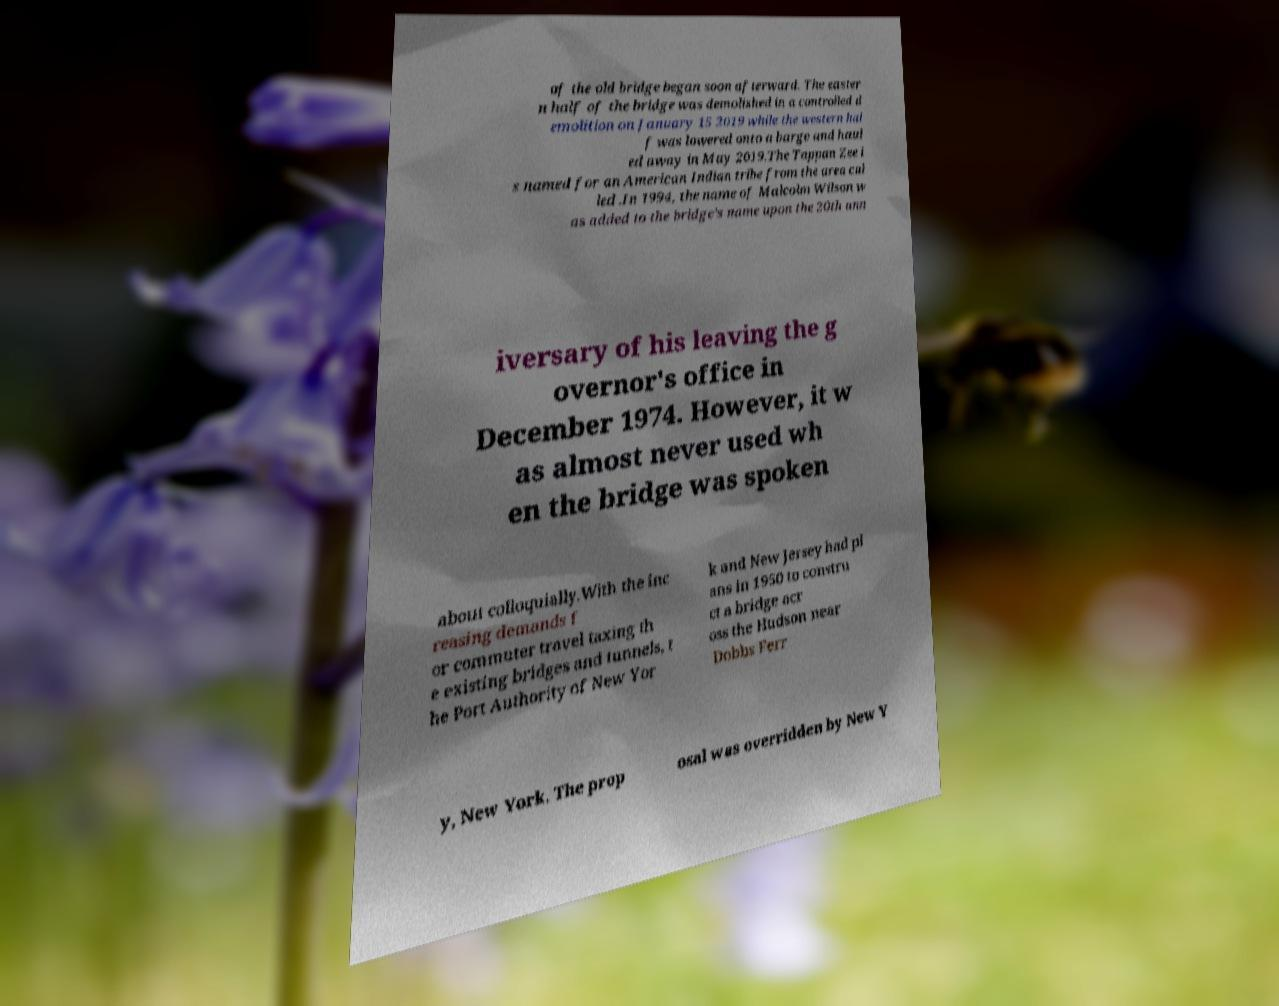Please identify and transcribe the text found in this image. of the old bridge began soon afterward. The easter n half of the bridge was demolished in a controlled d emolition on January 15 2019 while the western hal f was lowered onto a barge and haul ed away in May 2019.The Tappan Zee i s named for an American Indian tribe from the area cal led .In 1994, the name of Malcolm Wilson w as added to the bridge's name upon the 20th ann iversary of his leaving the g overnor's office in December 1974. However, it w as almost never used wh en the bridge was spoken about colloquially.With the inc reasing demands f or commuter travel taxing th e existing bridges and tunnels, t he Port Authority of New Yor k and New Jersey had pl ans in 1950 to constru ct a bridge acr oss the Hudson near Dobbs Ferr y, New York. The prop osal was overridden by New Y 